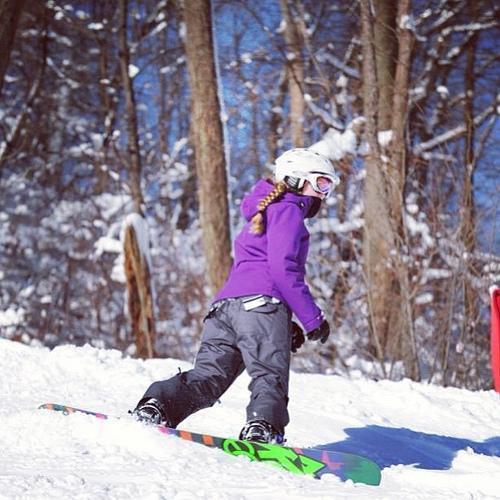How many people in picture?
Give a very brief answer. 1. 